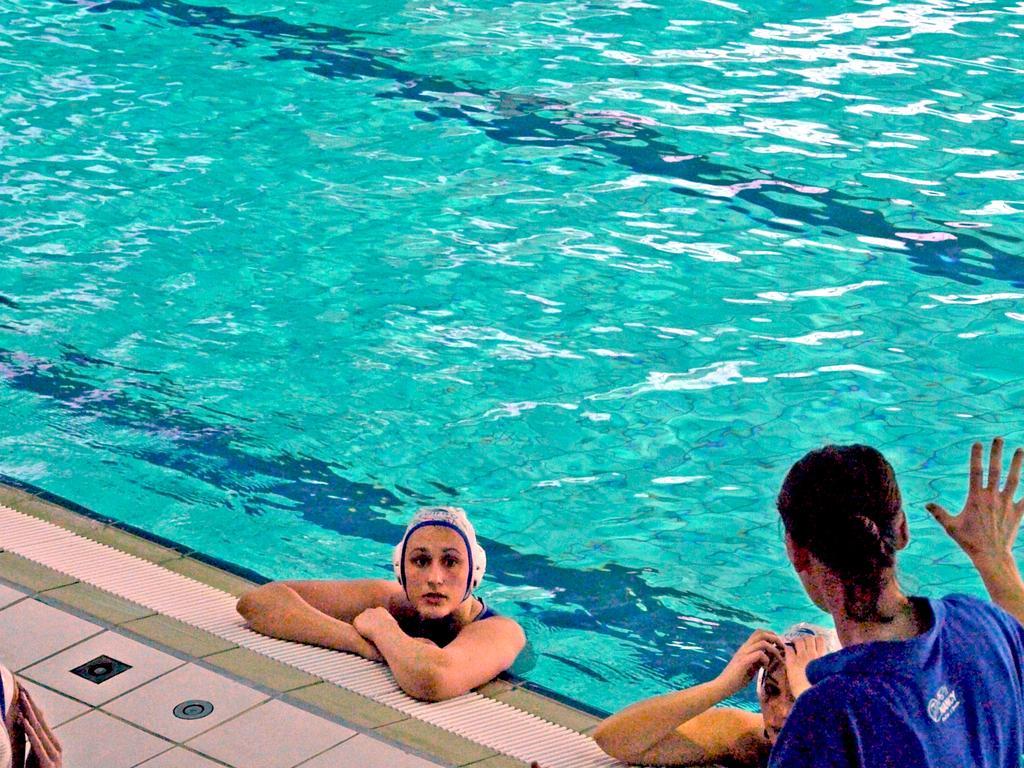How would you summarize this image in a sentence or two? This image is taken outdoors. At the bottom of the image there is a floor. On the right side of the image there is a woman. In the middle of the image there is a swimming pool and there are two women in the pool. 